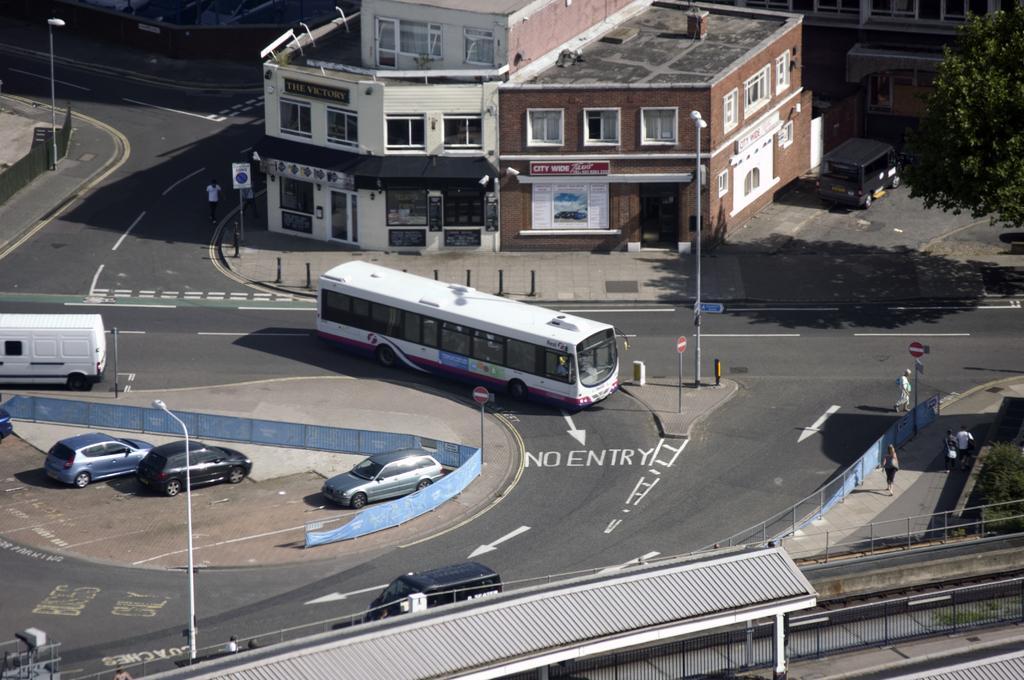Could you give a brief overview of what you see in this image? At the bottom we can see fences,poles,roof,plants. There are vehicles moving on the road and we can see light poles,sign board poles. There are three cars on the ground at the fence. In the background there are buildings,windows,glass doors,a person walking on the road on the left side and there are few persons on the right side and we can also see vehicles and a tree on the right side. 